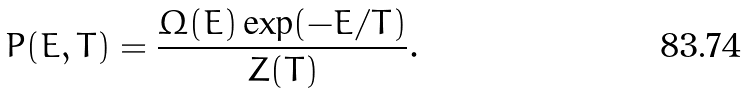Convert formula to latex. <formula><loc_0><loc_0><loc_500><loc_500>P ( E , T ) = \frac { \Omega ( E ) \exp ( - E / T ) } { Z ( T ) } .</formula> 